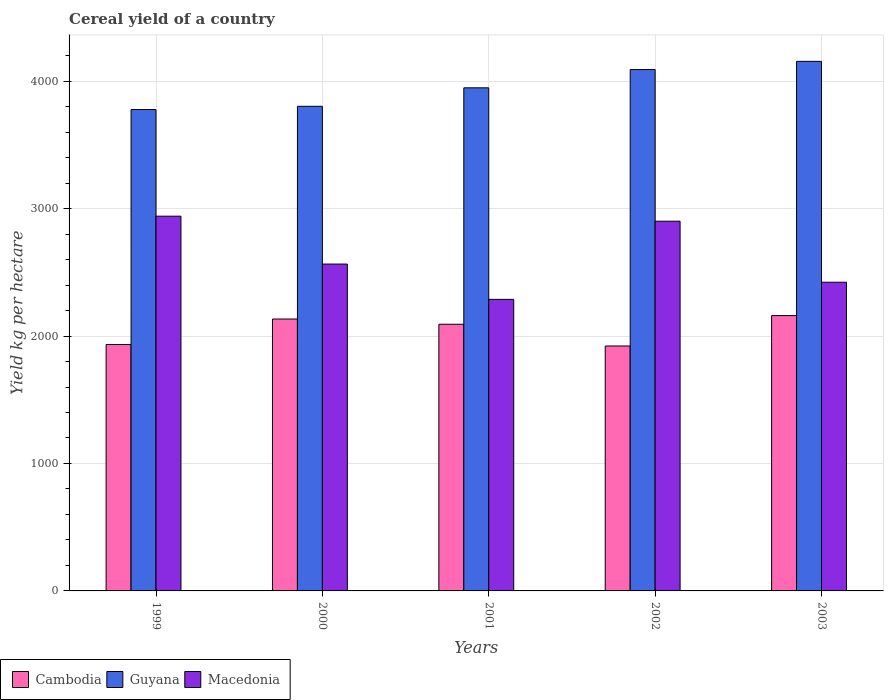How many bars are there on the 2nd tick from the left?
Give a very brief answer. 3. What is the label of the 1st group of bars from the left?
Provide a succinct answer. 1999. What is the total cereal yield in Cambodia in 1999?
Your answer should be very brief. 1933.53. Across all years, what is the maximum total cereal yield in Macedonia?
Give a very brief answer. 2940.61. Across all years, what is the minimum total cereal yield in Macedonia?
Provide a succinct answer. 2287.8. In which year was the total cereal yield in Guyana maximum?
Offer a very short reply. 2003. In which year was the total cereal yield in Macedonia minimum?
Give a very brief answer. 2001. What is the total total cereal yield in Macedonia in the graph?
Ensure brevity in your answer.  1.31e+04. What is the difference between the total cereal yield in Cambodia in 2001 and that in 2003?
Make the answer very short. -68.01. What is the difference between the total cereal yield in Macedonia in 2003 and the total cereal yield in Cambodia in 2002?
Offer a very short reply. 500.26. What is the average total cereal yield in Guyana per year?
Keep it short and to the point. 3955.03. In the year 1999, what is the difference between the total cereal yield in Macedonia and total cereal yield in Guyana?
Offer a very short reply. -836.9. In how many years, is the total cereal yield in Cambodia greater than 1600 kg per hectare?
Ensure brevity in your answer.  5. What is the ratio of the total cereal yield in Guyana in 2001 to that in 2003?
Your answer should be very brief. 0.95. Is the total cereal yield in Cambodia in 2002 less than that in 2003?
Offer a terse response. Yes. Is the difference between the total cereal yield in Macedonia in 1999 and 2000 greater than the difference between the total cereal yield in Guyana in 1999 and 2000?
Your answer should be compact. Yes. What is the difference between the highest and the second highest total cereal yield in Guyana?
Provide a succinct answer. 64.34. What is the difference between the highest and the lowest total cereal yield in Guyana?
Offer a very short reply. 378.07. In how many years, is the total cereal yield in Guyana greater than the average total cereal yield in Guyana taken over all years?
Offer a very short reply. 2. What does the 2nd bar from the left in 2000 represents?
Make the answer very short. Guyana. What does the 3rd bar from the right in 2001 represents?
Provide a short and direct response. Cambodia. Is it the case that in every year, the sum of the total cereal yield in Guyana and total cereal yield in Macedonia is greater than the total cereal yield in Cambodia?
Ensure brevity in your answer.  Yes. Are all the bars in the graph horizontal?
Your answer should be compact. No. What is the difference between two consecutive major ticks on the Y-axis?
Give a very brief answer. 1000. Does the graph contain grids?
Provide a succinct answer. Yes. How many legend labels are there?
Offer a terse response. 3. What is the title of the graph?
Provide a succinct answer. Cereal yield of a country. Does "Barbados" appear as one of the legend labels in the graph?
Give a very brief answer. No. What is the label or title of the X-axis?
Make the answer very short. Years. What is the label or title of the Y-axis?
Keep it short and to the point. Yield kg per hectare. What is the Yield kg per hectare of Cambodia in 1999?
Your response must be concise. 1933.53. What is the Yield kg per hectare in Guyana in 1999?
Ensure brevity in your answer.  3777.51. What is the Yield kg per hectare of Macedonia in 1999?
Your answer should be compact. 2940.61. What is the Yield kg per hectare of Cambodia in 2000?
Your response must be concise. 2133.6. What is the Yield kg per hectare in Guyana in 2000?
Keep it short and to the point. 3802.91. What is the Yield kg per hectare of Macedonia in 2000?
Offer a very short reply. 2565.01. What is the Yield kg per hectare of Cambodia in 2001?
Offer a terse response. 2092.59. What is the Yield kg per hectare of Guyana in 2001?
Provide a succinct answer. 3947.86. What is the Yield kg per hectare of Macedonia in 2001?
Give a very brief answer. 2287.8. What is the Yield kg per hectare of Cambodia in 2002?
Ensure brevity in your answer.  1922.05. What is the Yield kg per hectare in Guyana in 2002?
Your answer should be very brief. 4091.25. What is the Yield kg per hectare of Macedonia in 2002?
Your response must be concise. 2901.26. What is the Yield kg per hectare of Cambodia in 2003?
Provide a short and direct response. 2160.61. What is the Yield kg per hectare in Guyana in 2003?
Your response must be concise. 4155.59. What is the Yield kg per hectare of Macedonia in 2003?
Keep it short and to the point. 2422.31. Across all years, what is the maximum Yield kg per hectare of Cambodia?
Offer a terse response. 2160.61. Across all years, what is the maximum Yield kg per hectare of Guyana?
Offer a terse response. 4155.59. Across all years, what is the maximum Yield kg per hectare of Macedonia?
Offer a very short reply. 2940.61. Across all years, what is the minimum Yield kg per hectare in Cambodia?
Make the answer very short. 1922.05. Across all years, what is the minimum Yield kg per hectare in Guyana?
Provide a short and direct response. 3777.51. Across all years, what is the minimum Yield kg per hectare of Macedonia?
Provide a succinct answer. 2287.8. What is the total Yield kg per hectare of Cambodia in the graph?
Provide a succinct answer. 1.02e+04. What is the total Yield kg per hectare of Guyana in the graph?
Provide a short and direct response. 1.98e+04. What is the total Yield kg per hectare of Macedonia in the graph?
Provide a succinct answer. 1.31e+04. What is the difference between the Yield kg per hectare of Cambodia in 1999 and that in 2000?
Offer a very short reply. -200.07. What is the difference between the Yield kg per hectare in Guyana in 1999 and that in 2000?
Offer a very short reply. -25.39. What is the difference between the Yield kg per hectare of Macedonia in 1999 and that in 2000?
Your answer should be compact. 375.6. What is the difference between the Yield kg per hectare of Cambodia in 1999 and that in 2001?
Give a very brief answer. -159.06. What is the difference between the Yield kg per hectare of Guyana in 1999 and that in 2001?
Your answer should be compact. -170.35. What is the difference between the Yield kg per hectare in Macedonia in 1999 and that in 2001?
Your answer should be very brief. 652.8. What is the difference between the Yield kg per hectare of Cambodia in 1999 and that in 2002?
Give a very brief answer. 11.49. What is the difference between the Yield kg per hectare in Guyana in 1999 and that in 2002?
Ensure brevity in your answer.  -313.74. What is the difference between the Yield kg per hectare of Macedonia in 1999 and that in 2002?
Your response must be concise. 39.35. What is the difference between the Yield kg per hectare in Cambodia in 1999 and that in 2003?
Your answer should be compact. -227.07. What is the difference between the Yield kg per hectare in Guyana in 1999 and that in 2003?
Provide a short and direct response. -378.07. What is the difference between the Yield kg per hectare in Macedonia in 1999 and that in 2003?
Your response must be concise. 518.3. What is the difference between the Yield kg per hectare in Cambodia in 2000 and that in 2001?
Offer a terse response. 41.01. What is the difference between the Yield kg per hectare in Guyana in 2000 and that in 2001?
Your answer should be very brief. -144.96. What is the difference between the Yield kg per hectare in Macedonia in 2000 and that in 2001?
Make the answer very short. 277.21. What is the difference between the Yield kg per hectare in Cambodia in 2000 and that in 2002?
Your answer should be compact. 211.56. What is the difference between the Yield kg per hectare in Guyana in 2000 and that in 2002?
Your answer should be compact. -288.34. What is the difference between the Yield kg per hectare of Macedonia in 2000 and that in 2002?
Make the answer very short. -336.25. What is the difference between the Yield kg per hectare in Cambodia in 2000 and that in 2003?
Make the answer very short. -27. What is the difference between the Yield kg per hectare in Guyana in 2000 and that in 2003?
Your response must be concise. -352.68. What is the difference between the Yield kg per hectare in Macedonia in 2000 and that in 2003?
Your answer should be very brief. 142.7. What is the difference between the Yield kg per hectare of Cambodia in 2001 and that in 2002?
Your answer should be very brief. 170.55. What is the difference between the Yield kg per hectare in Guyana in 2001 and that in 2002?
Your response must be concise. -143.39. What is the difference between the Yield kg per hectare in Macedonia in 2001 and that in 2002?
Offer a very short reply. -613.45. What is the difference between the Yield kg per hectare of Cambodia in 2001 and that in 2003?
Keep it short and to the point. -68.01. What is the difference between the Yield kg per hectare in Guyana in 2001 and that in 2003?
Your response must be concise. -207.72. What is the difference between the Yield kg per hectare in Macedonia in 2001 and that in 2003?
Offer a terse response. -134.5. What is the difference between the Yield kg per hectare in Cambodia in 2002 and that in 2003?
Your answer should be compact. -238.56. What is the difference between the Yield kg per hectare of Guyana in 2002 and that in 2003?
Offer a terse response. -64.34. What is the difference between the Yield kg per hectare of Macedonia in 2002 and that in 2003?
Your answer should be compact. 478.95. What is the difference between the Yield kg per hectare of Cambodia in 1999 and the Yield kg per hectare of Guyana in 2000?
Offer a terse response. -1869.38. What is the difference between the Yield kg per hectare of Cambodia in 1999 and the Yield kg per hectare of Macedonia in 2000?
Your answer should be compact. -631.48. What is the difference between the Yield kg per hectare of Guyana in 1999 and the Yield kg per hectare of Macedonia in 2000?
Offer a terse response. 1212.5. What is the difference between the Yield kg per hectare in Cambodia in 1999 and the Yield kg per hectare in Guyana in 2001?
Your answer should be compact. -2014.33. What is the difference between the Yield kg per hectare in Cambodia in 1999 and the Yield kg per hectare in Macedonia in 2001?
Make the answer very short. -354.27. What is the difference between the Yield kg per hectare in Guyana in 1999 and the Yield kg per hectare in Macedonia in 2001?
Your response must be concise. 1489.71. What is the difference between the Yield kg per hectare in Cambodia in 1999 and the Yield kg per hectare in Guyana in 2002?
Offer a terse response. -2157.72. What is the difference between the Yield kg per hectare of Cambodia in 1999 and the Yield kg per hectare of Macedonia in 2002?
Your answer should be compact. -967.73. What is the difference between the Yield kg per hectare of Guyana in 1999 and the Yield kg per hectare of Macedonia in 2002?
Make the answer very short. 876.26. What is the difference between the Yield kg per hectare in Cambodia in 1999 and the Yield kg per hectare in Guyana in 2003?
Provide a short and direct response. -2222.06. What is the difference between the Yield kg per hectare in Cambodia in 1999 and the Yield kg per hectare in Macedonia in 2003?
Provide a succinct answer. -488.78. What is the difference between the Yield kg per hectare in Guyana in 1999 and the Yield kg per hectare in Macedonia in 2003?
Keep it short and to the point. 1355.21. What is the difference between the Yield kg per hectare of Cambodia in 2000 and the Yield kg per hectare of Guyana in 2001?
Your answer should be compact. -1814.26. What is the difference between the Yield kg per hectare of Cambodia in 2000 and the Yield kg per hectare of Macedonia in 2001?
Ensure brevity in your answer.  -154.2. What is the difference between the Yield kg per hectare of Guyana in 2000 and the Yield kg per hectare of Macedonia in 2001?
Offer a very short reply. 1515.1. What is the difference between the Yield kg per hectare of Cambodia in 2000 and the Yield kg per hectare of Guyana in 2002?
Keep it short and to the point. -1957.65. What is the difference between the Yield kg per hectare of Cambodia in 2000 and the Yield kg per hectare of Macedonia in 2002?
Provide a succinct answer. -767.65. What is the difference between the Yield kg per hectare of Guyana in 2000 and the Yield kg per hectare of Macedonia in 2002?
Keep it short and to the point. 901.65. What is the difference between the Yield kg per hectare in Cambodia in 2000 and the Yield kg per hectare in Guyana in 2003?
Offer a very short reply. -2021.99. What is the difference between the Yield kg per hectare in Cambodia in 2000 and the Yield kg per hectare in Macedonia in 2003?
Your response must be concise. -288.71. What is the difference between the Yield kg per hectare in Guyana in 2000 and the Yield kg per hectare in Macedonia in 2003?
Your response must be concise. 1380.6. What is the difference between the Yield kg per hectare in Cambodia in 2001 and the Yield kg per hectare in Guyana in 2002?
Make the answer very short. -1998.66. What is the difference between the Yield kg per hectare of Cambodia in 2001 and the Yield kg per hectare of Macedonia in 2002?
Your response must be concise. -808.66. What is the difference between the Yield kg per hectare of Guyana in 2001 and the Yield kg per hectare of Macedonia in 2002?
Ensure brevity in your answer.  1046.61. What is the difference between the Yield kg per hectare of Cambodia in 2001 and the Yield kg per hectare of Guyana in 2003?
Make the answer very short. -2062.99. What is the difference between the Yield kg per hectare of Cambodia in 2001 and the Yield kg per hectare of Macedonia in 2003?
Make the answer very short. -329.71. What is the difference between the Yield kg per hectare in Guyana in 2001 and the Yield kg per hectare in Macedonia in 2003?
Make the answer very short. 1525.56. What is the difference between the Yield kg per hectare of Cambodia in 2002 and the Yield kg per hectare of Guyana in 2003?
Offer a very short reply. -2233.54. What is the difference between the Yield kg per hectare of Cambodia in 2002 and the Yield kg per hectare of Macedonia in 2003?
Ensure brevity in your answer.  -500.26. What is the difference between the Yield kg per hectare of Guyana in 2002 and the Yield kg per hectare of Macedonia in 2003?
Your answer should be compact. 1668.94. What is the average Yield kg per hectare in Cambodia per year?
Your answer should be compact. 2048.48. What is the average Yield kg per hectare of Guyana per year?
Make the answer very short. 3955.03. What is the average Yield kg per hectare of Macedonia per year?
Ensure brevity in your answer.  2623.4. In the year 1999, what is the difference between the Yield kg per hectare in Cambodia and Yield kg per hectare in Guyana?
Provide a short and direct response. -1843.98. In the year 1999, what is the difference between the Yield kg per hectare in Cambodia and Yield kg per hectare in Macedonia?
Provide a succinct answer. -1007.08. In the year 1999, what is the difference between the Yield kg per hectare in Guyana and Yield kg per hectare in Macedonia?
Keep it short and to the point. 836.9. In the year 2000, what is the difference between the Yield kg per hectare of Cambodia and Yield kg per hectare of Guyana?
Provide a short and direct response. -1669.31. In the year 2000, what is the difference between the Yield kg per hectare of Cambodia and Yield kg per hectare of Macedonia?
Ensure brevity in your answer.  -431.41. In the year 2000, what is the difference between the Yield kg per hectare in Guyana and Yield kg per hectare in Macedonia?
Make the answer very short. 1237.9. In the year 2001, what is the difference between the Yield kg per hectare in Cambodia and Yield kg per hectare in Guyana?
Provide a succinct answer. -1855.27. In the year 2001, what is the difference between the Yield kg per hectare in Cambodia and Yield kg per hectare in Macedonia?
Ensure brevity in your answer.  -195.21. In the year 2001, what is the difference between the Yield kg per hectare of Guyana and Yield kg per hectare of Macedonia?
Give a very brief answer. 1660.06. In the year 2002, what is the difference between the Yield kg per hectare of Cambodia and Yield kg per hectare of Guyana?
Keep it short and to the point. -2169.2. In the year 2002, what is the difference between the Yield kg per hectare in Cambodia and Yield kg per hectare in Macedonia?
Your response must be concise. -979.21. In the year 2002, what is the difference between the Yield kg per hectare of Guyana and Yield kg per hectare of Macedonia?
Your response must be concise. 1189.99. In the year 2003, what is the difference between the Yield kg per hectare in Cambodia and Yield kg per hectare in Guyana?
Provide a short and direct response. -1994.98. In the year 2003, what is the difference between the Yield kg per hectare of Cambodia and Yield kg per hectare of Macedonia?
Give a very brief answer. -261.7. In the year 2003, what is the difference between the Yield kg per hectare in Guyana and Yield kg per hectare in Macedonia?
Offer a very short reply. 1733.28. What is the ratio of the Yield kg per hectare in Cambodia in 1999 to that in 2000?
Offer a very short reply. 0.91. What is the ratio of the Yield kg per hectare of Macedonia in 1999 to that in 2000?
Provide a succinct answer. 1.15. What is the ratio of the Yield kg per hectare of Cambodia in 1999 to that in 2001?
Make the answer very short. 0.92. What is the ratio of the Yield kg per hectare in Guyana in 1999 to that in 2001?
Give a very brief answer. 0.96. What is the ratio of the Yield kg per hectare of Macedonia in 1999 to that in 2001?
Keep it short and to the point. 1.29. What is the ratio of the Yield kg per hectare of Cambodia in 1999 to that in 2002?
Your answer should be compact. 1.01. What is the ratio of the Yield kg per hectare of Guyana in 1999 to that in 2002?
Your answer should be compact. 0.92. What is the ratio of the Yield kg per hectare of Macedonia in 1999 to that in 2002?
Give a very brief answer. 1.01. What is the ratio of the Yield kg per hectare of Cambodia in 1999 to that in 2003?
Your answer should be compact. 0.89. What is the ratio of the Yield kg per hectare in Guyana in 1999 to that in 2003?
Make the answer very short. 0.91. What is the ratio of the Yield kg per hectare in Macedonia in 1999 to that in 2003?
Your answer should be compact. 1.21. What is the ratio of the Yield kg per hectare in Cambodia in 2000 to that in 2001?
Keep it short and to the point. 1.02. What is the ratio of the Yield kg per hectare of Guyana in 2000 to that in 2001?
Give a very brief answer. 0.96. What is the ratio of the Yield kg per hectare in Macedonia in 2000 to that in 2001?
Provide a succinct answer. 1.12. What is the ratio of the Yield kg per hectare in Cambodia in 2000 to that in 2002?
Offer a very short reply. 1.11. What is the ratio of the Yield kg per hectare in Guyana in 2000 to that in 2002?
Make the answer very short. 0.93. What is the ratio of the Yield kg per hectare in Macedonia in 2000 to that in 2002?
Offer a terse response. 0.88. What is the ratio of the Yield kg per hectare in Cambodia in 2000 to that in 2003?
Your answer should be very brief. 0.99. What is the ratio of the Yield kg per hectare of Guyana in 2000 to that in 2003?
Offer a very short reply. 0.92. What is the ratio of the Yield kg per hectare of Macedonia in 2000 to that in 2003?
Provide a succinct answer. 1.06. What is the ratio of the Yield kg per hectare in Cambodia in 2001 to that in 2002?
Provide a succinct answer. 1.09. What is the ratio of the Yield kg per hectare in Macedonia in 2001 to that in 2002?
Your response must be concise. 0.79. What is the ratio of the Yield kg per hectare of Cambodia in 2001 to that in 2003?
Provide a succinct answer. 0.97. What is the ratio of the Yield kg per hectare in Guyana in 2001 to that in 2003?
Make the answer very short. 0.95. What is the ratio of the Yield kg per hectare in Macedonia in 2001 to that in 2003?
Provide a succinct answer. 0.94. What is the ratio of the Yield kg per hectare of Cambodia in 2002 to that in 2003?
Provide a succinct answer. 0.89. What is the ratio of the Yield kg per hectare in Guyana in 2002 to that in 2003?
Your answer should be very brief. 0.98. What is the ratio of the Yield kg per hectare in Macedonia in 2002 to that in 2003?
Make the answer very short. 1.2. What is the difference between the highest and the second highest Yield kg per hectare in Cambodia?
Your answer should be very brief. 27. What is the difference between the highest and the second highest Yield kg per hectare of Guyana?
Make the answer very short. 64.34. What is the difference between the highest and the second highest Yield kg per hectare in Macedonia?
Your answer should be very brief. 39.35. What is the difference between the highest and the lowest Yield kg per hectare in Cambodia?
Give a very brief answer. 238.56. What is the difference between the highest and the lowest Yield kg per hectare in Guyana?
Keep it short and to the point. 378.07. What is the difference between the highest and the lowest Yield kg per hectare in Macedonia?
Your answer should be very brief. 652.8. 